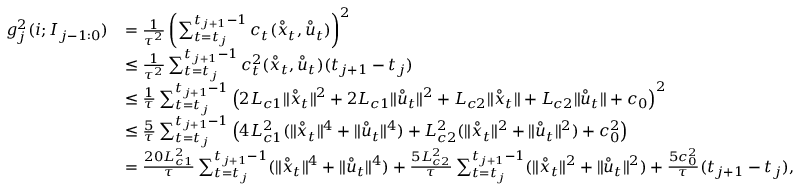Convert formula to latex. <formula><loc_0><loc_0><loc_500><loc_500>\begin{array} { r l } { g _ { j } ^ { 2 } ( i ; I _ { j - 1 \colon 0 } ) } & { = \frac { 1 } { \tau ^ { 2 } } \left ( \sum _ { t = t _ { j } } ^ { t _ { j + 1 } - 1 } c _ { t } ( \mathring { x } _ { t } , \mathring { u } _ { t } ) \right ) ^ { 2 } } \\ & { \leq \frac { 1 } { \tau ^ { 2 } } \sum _ { t = t _ { j } } ^ { t _ { j + 1 } - 1 } c _ { t } ^ { 2 } ( \mathring { x } _ { t } , \mathring { u } _ { t } ) ( t _ { j + 1 } - t _ { j } ) } \\ & { \leq \frac { 1 } { \tau } \sum _ { t = t _ { j } } ^ { t _ { j + 1 } - 1 } \left ( 2 L _ { c 1 } \| \mathring { x } _ { t } \| ^ { 2 } + 2 L _ { c 1 } \| \mathring { u } _ { t } \| ^ { 2 } + L _ { c 2 } \| \mathring { x } _ { t } \| + L _ { c 2 } \| \mathring { u } _ { t } \| + c _ { 0 } \right ) ^ { 2 } } \\ & { \leq \frac { 5 } { \tau } \sum _ { t = t _ { j } } ^ { t _ { j + 1 } - 1 } \left ( 4 L _ { c 1 } ^ { 2 } ( \| \mathring { x } _ { t } \| ^ { 4 } + \| \mathring { u } _ { t } \| ^ { 4 } ) + L _ { c 2 } ^ { 2 } ( \| \mathring { x } _ { t } \| ^ { 2 } + \| \mathring { u } _ { t } \| ^ { 2 } ) + c _ { 0 } ^ { 2 } \right ) } \\ & { = \frac { 2 0 L _ { c 1 } ^ { 2 } } { \tau } \sum _ { t = t _ { j } } ^ { t _ { j + 1 } - 1 } ( \| \mathring { x } _ { t } \| ^ { 4 } + \| \mathring { u } _ { t } \| ^ { 4 } ) + \frac { 5 L _ { c 2 } ^ { 2 } } { \tau } \sum _ { t = t _ { j } } ^ { t _ { j + 1 } - 1 } ( \| \mathring { x } _ { t } \| ^ { 2 } + \| \mathring { u } _ { t } \| ^ { 2 } ) + \frac { 5 c _ { 0 } ^ { 2 } } { \tau } ( t _ { j + 1 } - t _ { j } ) , } \end{array}</formula> 